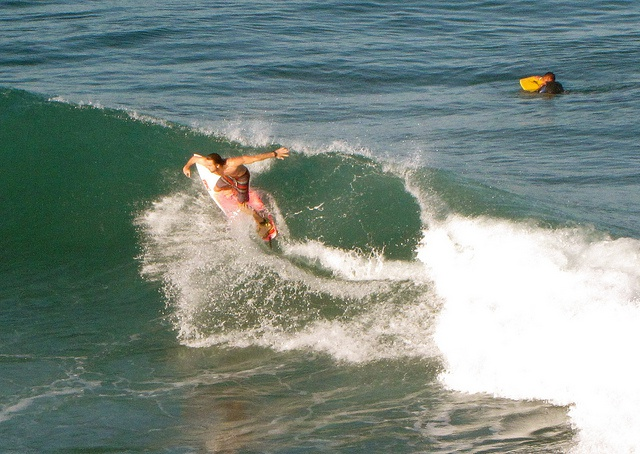Describe the objects in this image and their specific colors. I can see people in teal, tan, gray, and brown tones, surfboard in teal, white, lightpink, and tan tones, people in teal, black, maroon, red, and gray tones, and surfboard in teal, orange, gold, and olive tones in this image. 